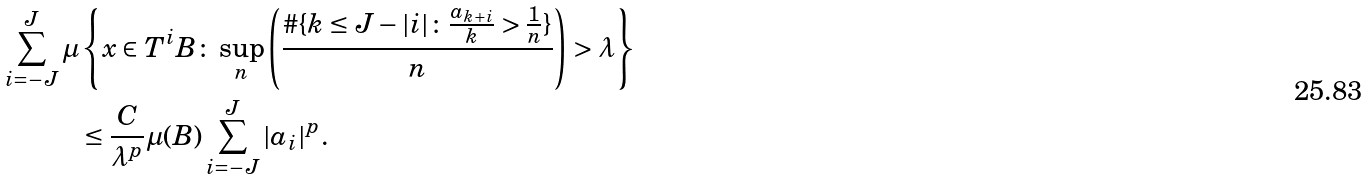<formula> <loc_0><loc_0><loc_500><loc_500>\sum _ { i = - J } ^ { J } \mu & \left \{ x \in T ^ { i } B \colon \sup _ { n } \left ( \frac { \# \{ k \leq J - | i | \colon \frac { a _ { k + i } } { k } > \frac { 1 } { n } \} } { n } \right ) > \lambda \right \} \\ & \leq \frac { C } { \lambda ^ { p } } \mu ( B ) \sum _ { i = - J } ^ { J } | a _ { i } | ^ { p } .</formula> 